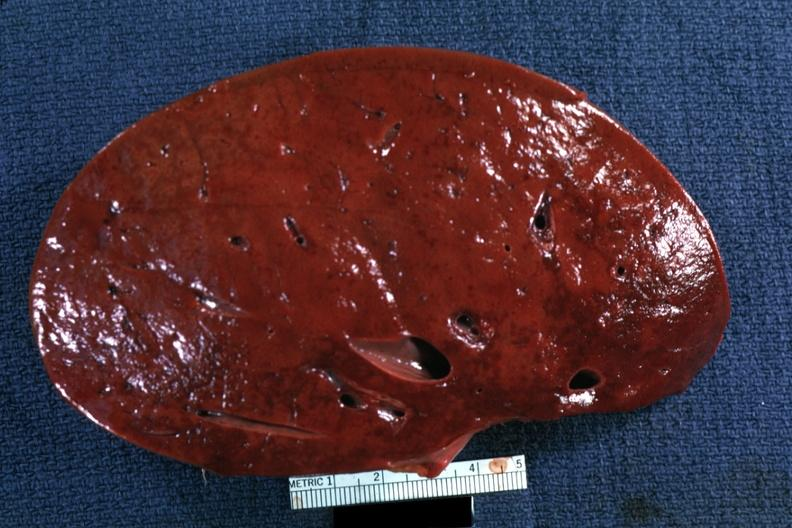where is this part in?
Answer the question using a single word or phrase. Spleen 